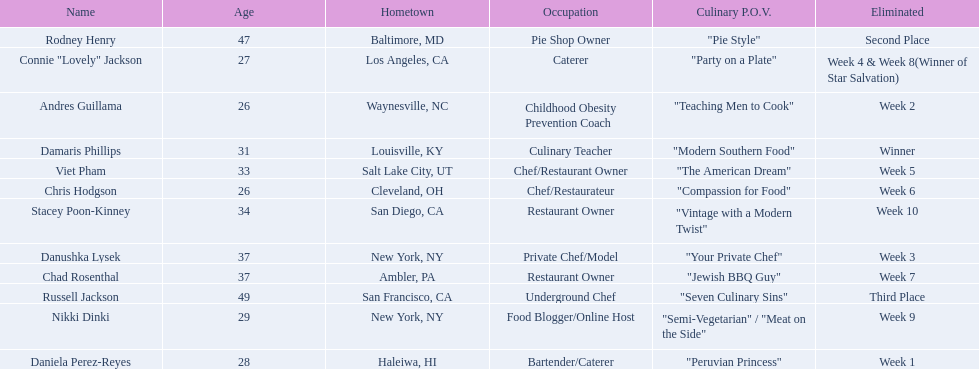Who are all of the people listed? Damaris Phillips, Rodney Henry, Russell Jackson, Stacey Poon-Kinney, Nikki Dinki, Chad Rosenthal, Chris Hodgson, Viet Pham, Connie "Lovely" Jackson, Danushka Lysek, Andres Guillama, Daniela Perez-Reyes. How old are they? 31, 47, 49, 34, 29, 37, 26, 33, 27, 37, 26, 28. Along with chris hodgson, which other person is 26 years old? Andres Guillama. 